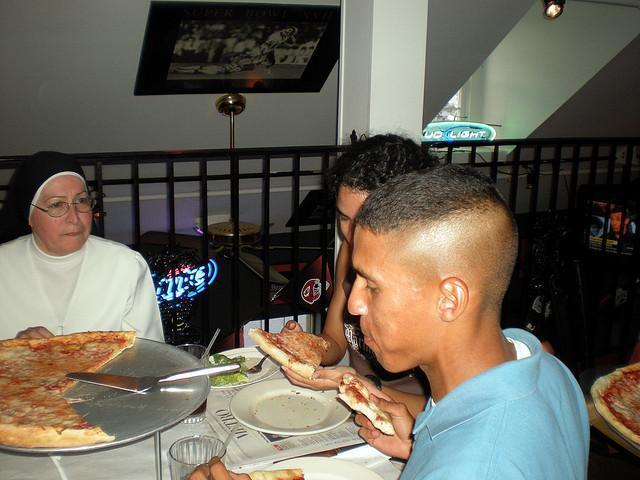What is this woman's profession?
Select the accurate answer and provide justification: `Answer: choice
Rationale: srationale.`
Options: Waitress, nun, clown, janitor. Answer: nun.
Rationale: The woman is a nun. 